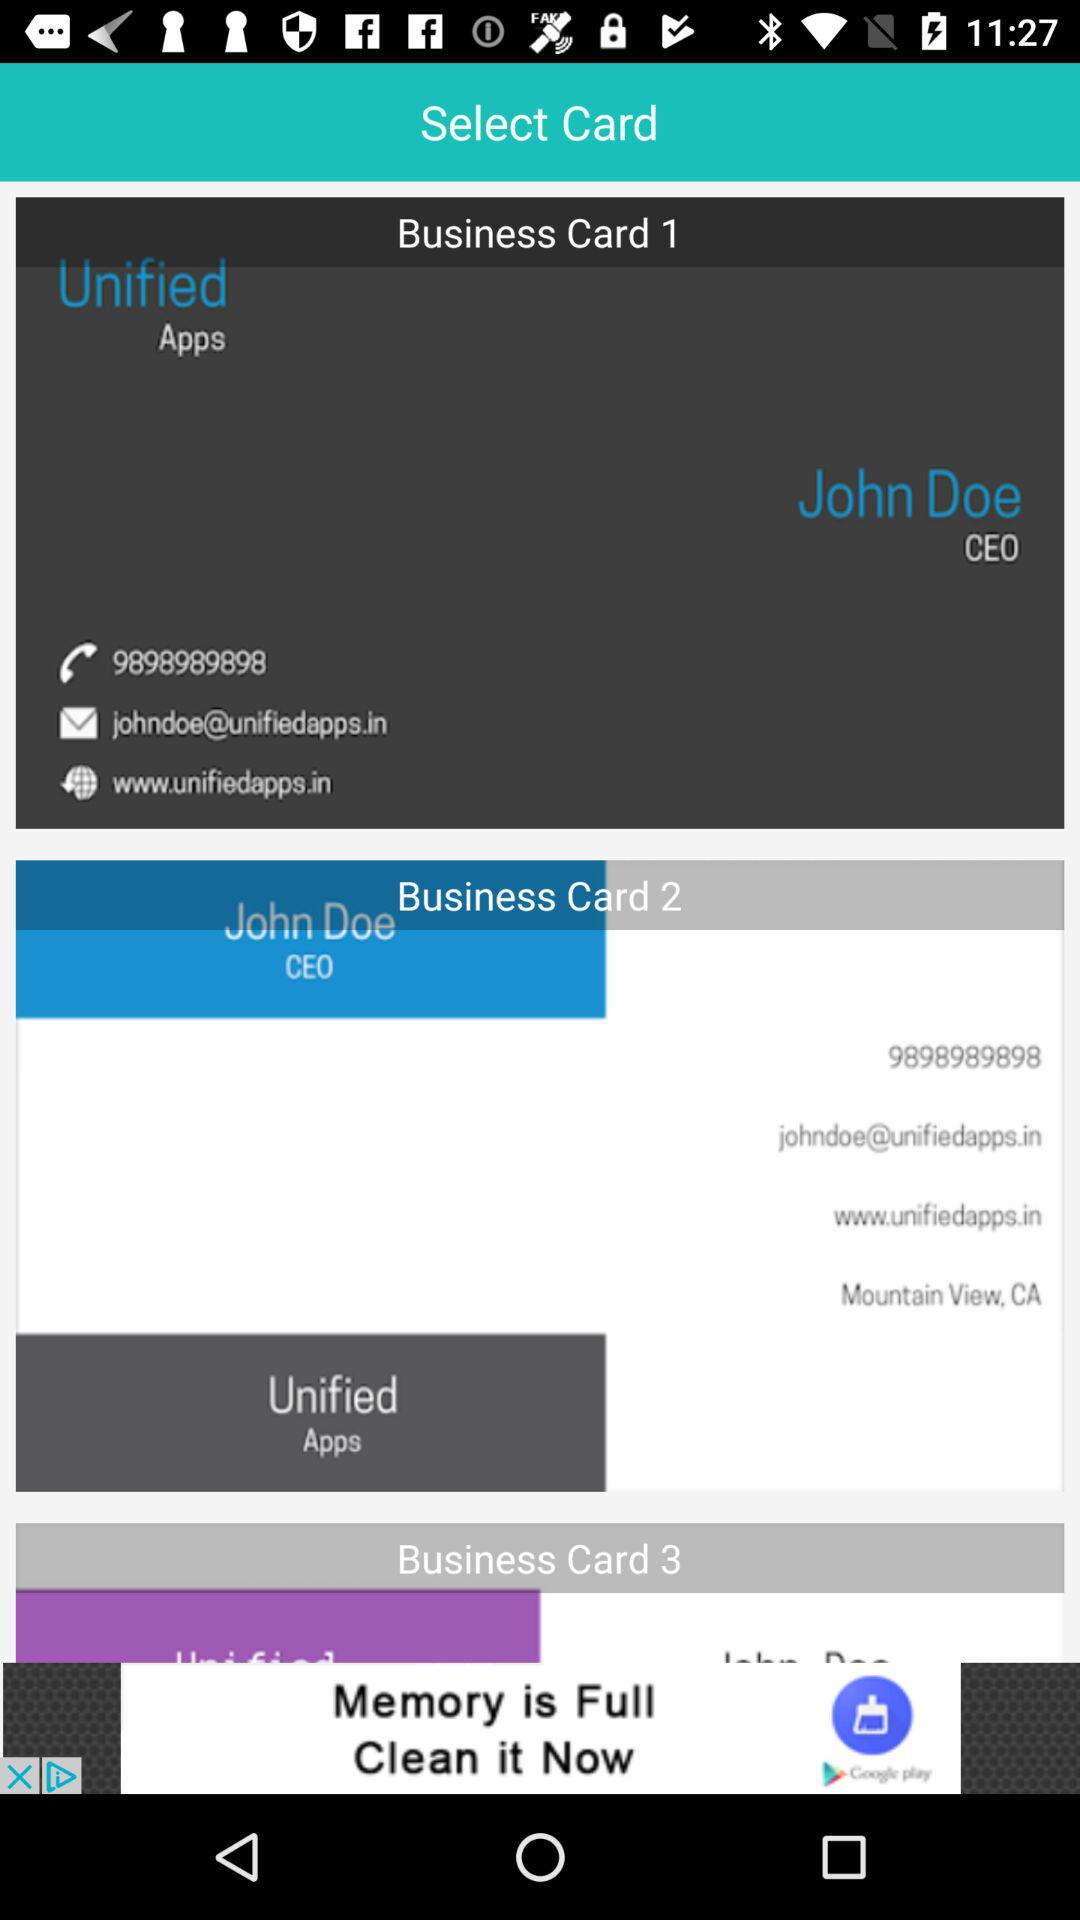What's the phone number? The phone number is 9898989898. 